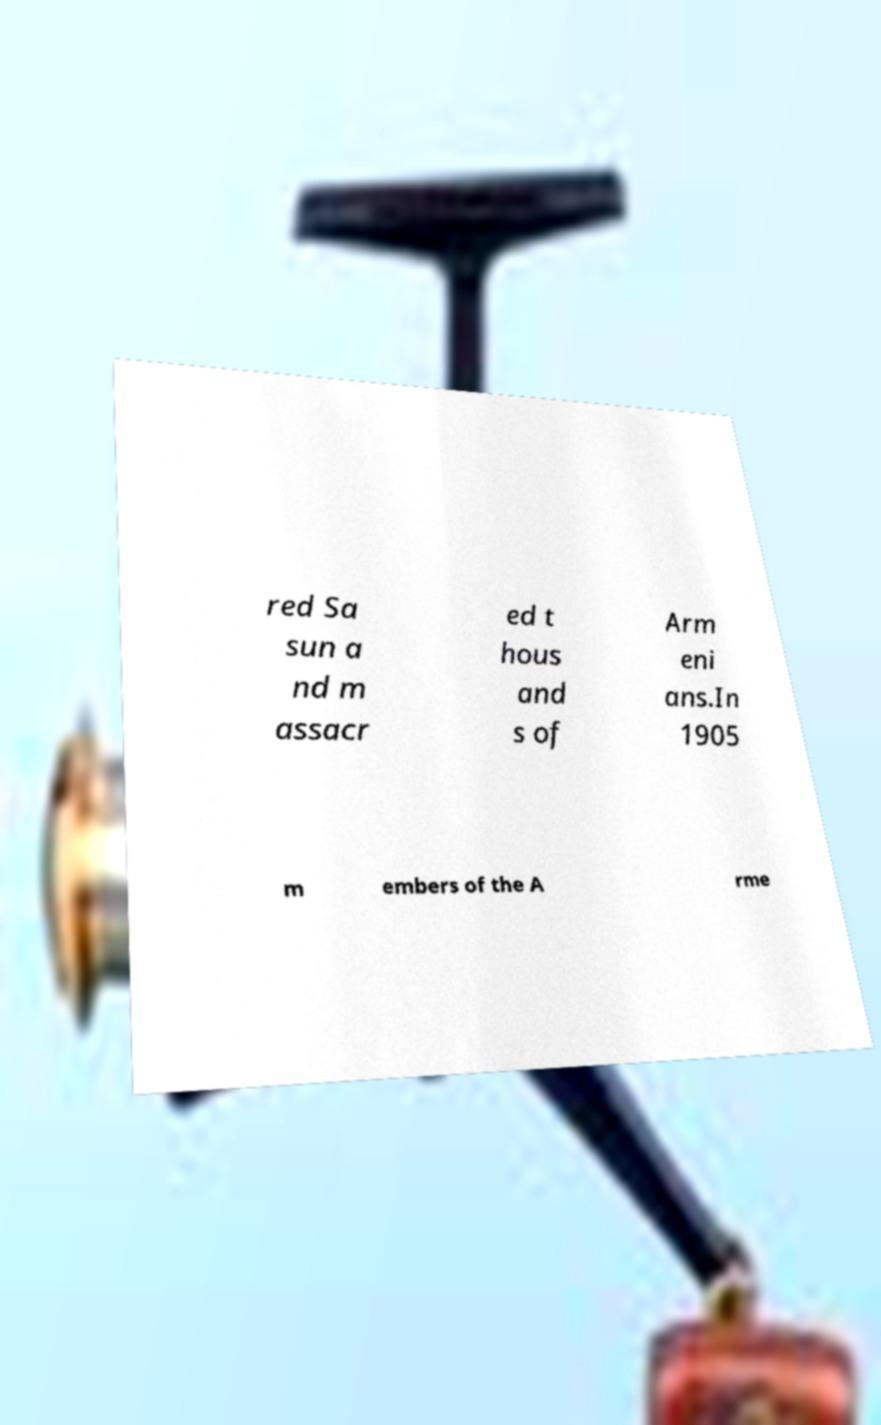Could you assist in decoding the text presented in this image and type it out clearly? red Sa sun a nd m assacr ed t hous and s of Arm eni ans.In 1905 m embers of the A rme 